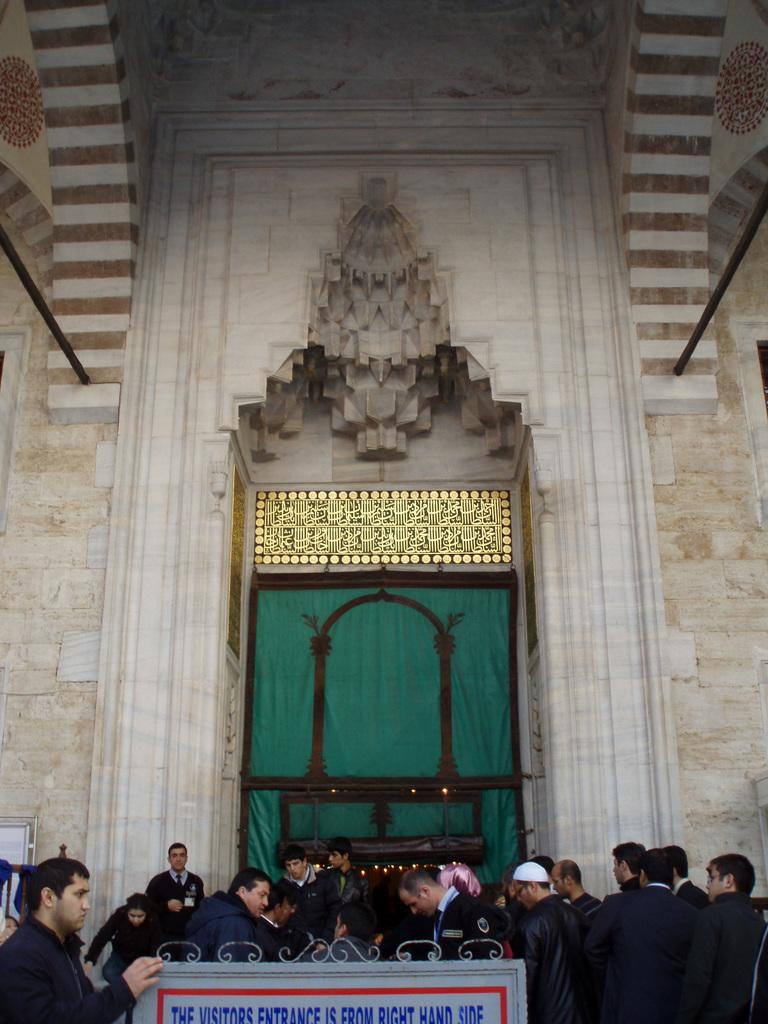Who or what is present in the image? There are people in the image. What are the people wearing? The people are wearing clothes. What is at the bottom of the image? There is a board at the bottom of the image. What can be seen in the background of the image? There is a wall in the background of the image. How many cans are being used by the people in the image? There is no mention of cans in the image, so it cannot be determined how many cans are being used. 